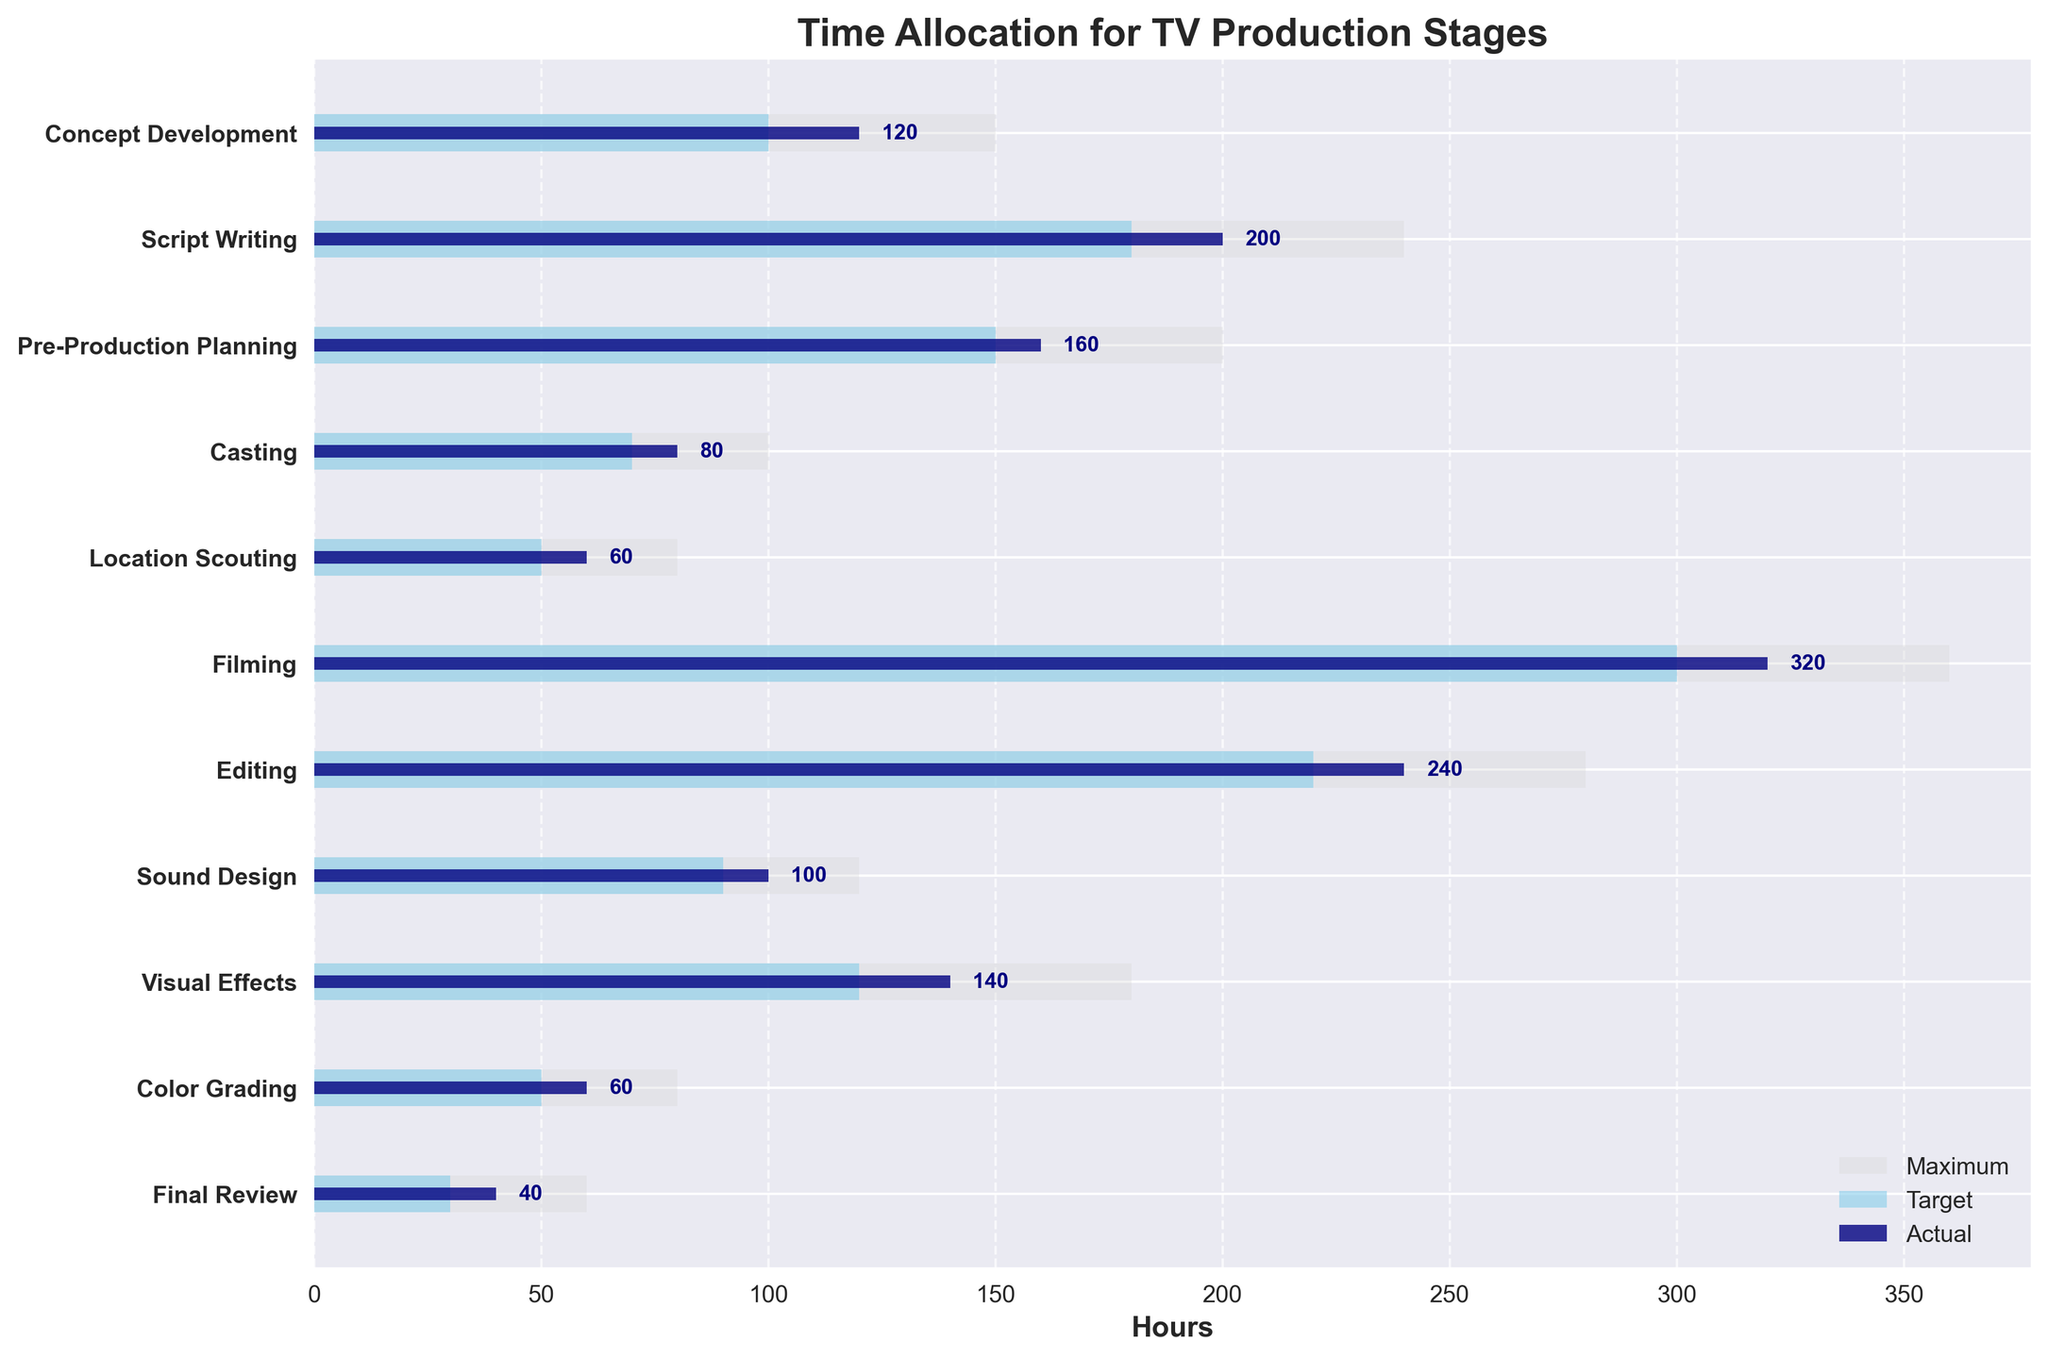What's the title of the chart? The title of the chart is displayed at the top of the figure. It reads "Time Allocation for TV Production Stages".
Answer: Time Allocation for TV Production Stages How many stages are depicted in the chart? The chart shows 11 distinct stages of TV production, which can be counted along the y-axis.
Answer: 11 What color represents the actual hours on the chart? The color representing the actual hours on the chart is navy blue, as indicated in the legend.
Answer: navy blue Which stage had the highest target hours? By comparing the length of the sky blue bars, the Filming stage had the highest target hours, at 300 hours.
Answer: Filming What's the total number of actual hours spent on Script Writing and Editing combined? Adding the actual hours for Script Writing (200) and Editing (240), the total is 200 + 240 = 440 hours.
Answer: 440 hours How does the actual time spent on Location Scouting compare to its maximum and target hours? The actual hours spent on Location Scouting is 60, while its target is 50 and its maximum is 80. The actual time exceeds the target by 10 hours and is 20 hours less than the maximum.
Answer: 60 (Actual), 50 (Target), 80 (Maximum) Which stage exceeded the target hours by the largest margin? By comparing the difference between actual and target hours, the Script Writing stage exceeded its target by 200 - 180 = 20 hours. This is the largest margin among all stages.
Answer: Script Writing What is the average actual hours for the stages of Editing, Sound Design, and Visual Effects? Summing the actual hours for Editing (240), Sound Design (100), and Visual Effects (140) gives 240 + 100 + 140 = 480. Dividing by 3 stages gives 480 / 3 = 160 hours.
Answer: 160 hours What stages have actual hours that exactly match their target hours? Comparing the actual and target hours for all stages, only the stages of Filming and Location Scouting have actual hours (320 and 60, respectively) that match their target hours (320 and 60, respectively).
Answer: Filming, Location Scouting Which stage shows the least variance between actual and maximum hours? The variance between actual and maximum hours is smallest for Final Review, with actual hours of 40 and maximum hours of 60, a difference of 20 hours.
Answer: Final Review 